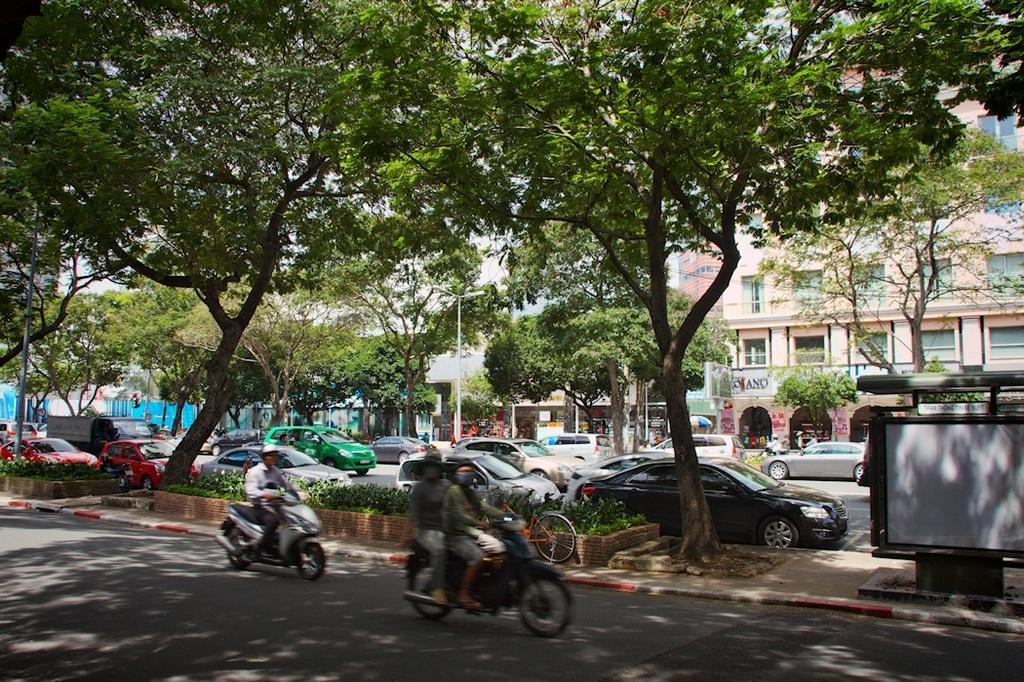How would you summarize this image in a sentence or two? At the bottom we can see few persons are riding vehicles on the road. There are trees,board and a metal object. In the background we can see vehicles on the road, trees, building, light poles, windows, hoardings and sky. 